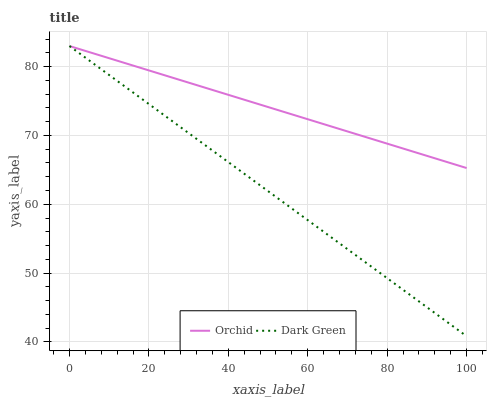Does Dark Green have the minimum area under the curve?
Answer yes or no. Yes. Does Orchid have the maximum area under the curve?
Answer yes or no. Yes. Does Orchid have the minimum area under the curve?
Answer yes or no. No. Is Dark Green the smoothest?
Answer yes or no. Yes. Is Orchid the roughest?
Answer yes or no. Yes. Is Orchid the smoothest?
Answer yes or no. No. Does Dark Green have the lowest value?
Answer yes or no. Yes. Does Orchid have the lowest value?
Answer yes or no. No. Does Orchid have the highest value?
Answer yes or no. Yes. Does Dark Green intersect Orchid?
Answer yes or no. Yes. Is Dark Green less than Orchid?
Answer yes or no. No. Is Dark Green greater than Orchid?
Answer yes or no. No. 